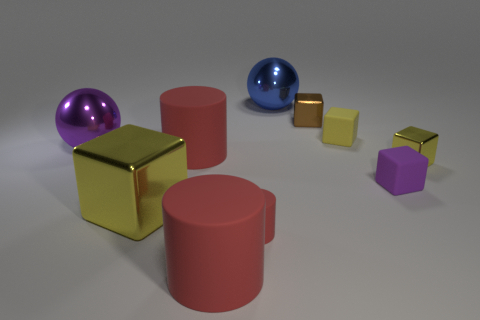What is the shape of the purple thing right of the tiny cylinder? cube 